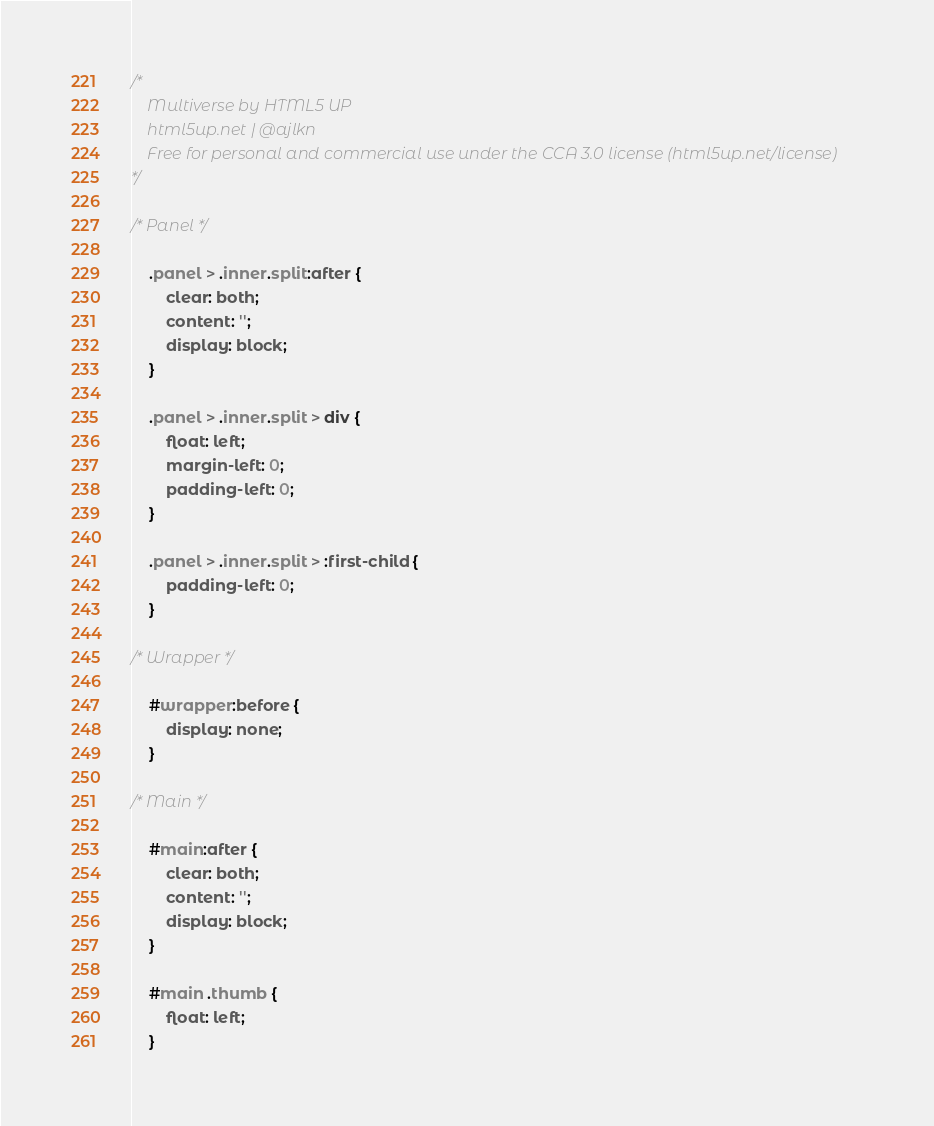Convert code to text. <code><loc_0><loc_0><loc_500><loc_500><_CSS_>/*
	Multiverse by HTML5 UP
	html5up.net | @ajlkn
	Free for personal and commercial use under the CCA 3.0 license (html5up.net/license)
*/

/* Panel */

	.panel > .inner.split:after {
		clear: both;
		content: '';
		display: block;
	}

	.panel > .inner.split > div {
		float: left;
		margin-left: 0;
		padding-left: 0;
	}

	.panel > .inner.split > :first-child {
		padding-left: 0;
	}

/* Wrapper */

	#wrapper:before {
		display: none;
	}

/* Main */

	#main:after {
		clear: both;
		content: '';
		display: block;
	}

	#main .thumb {
		float: left;
	}</code> 